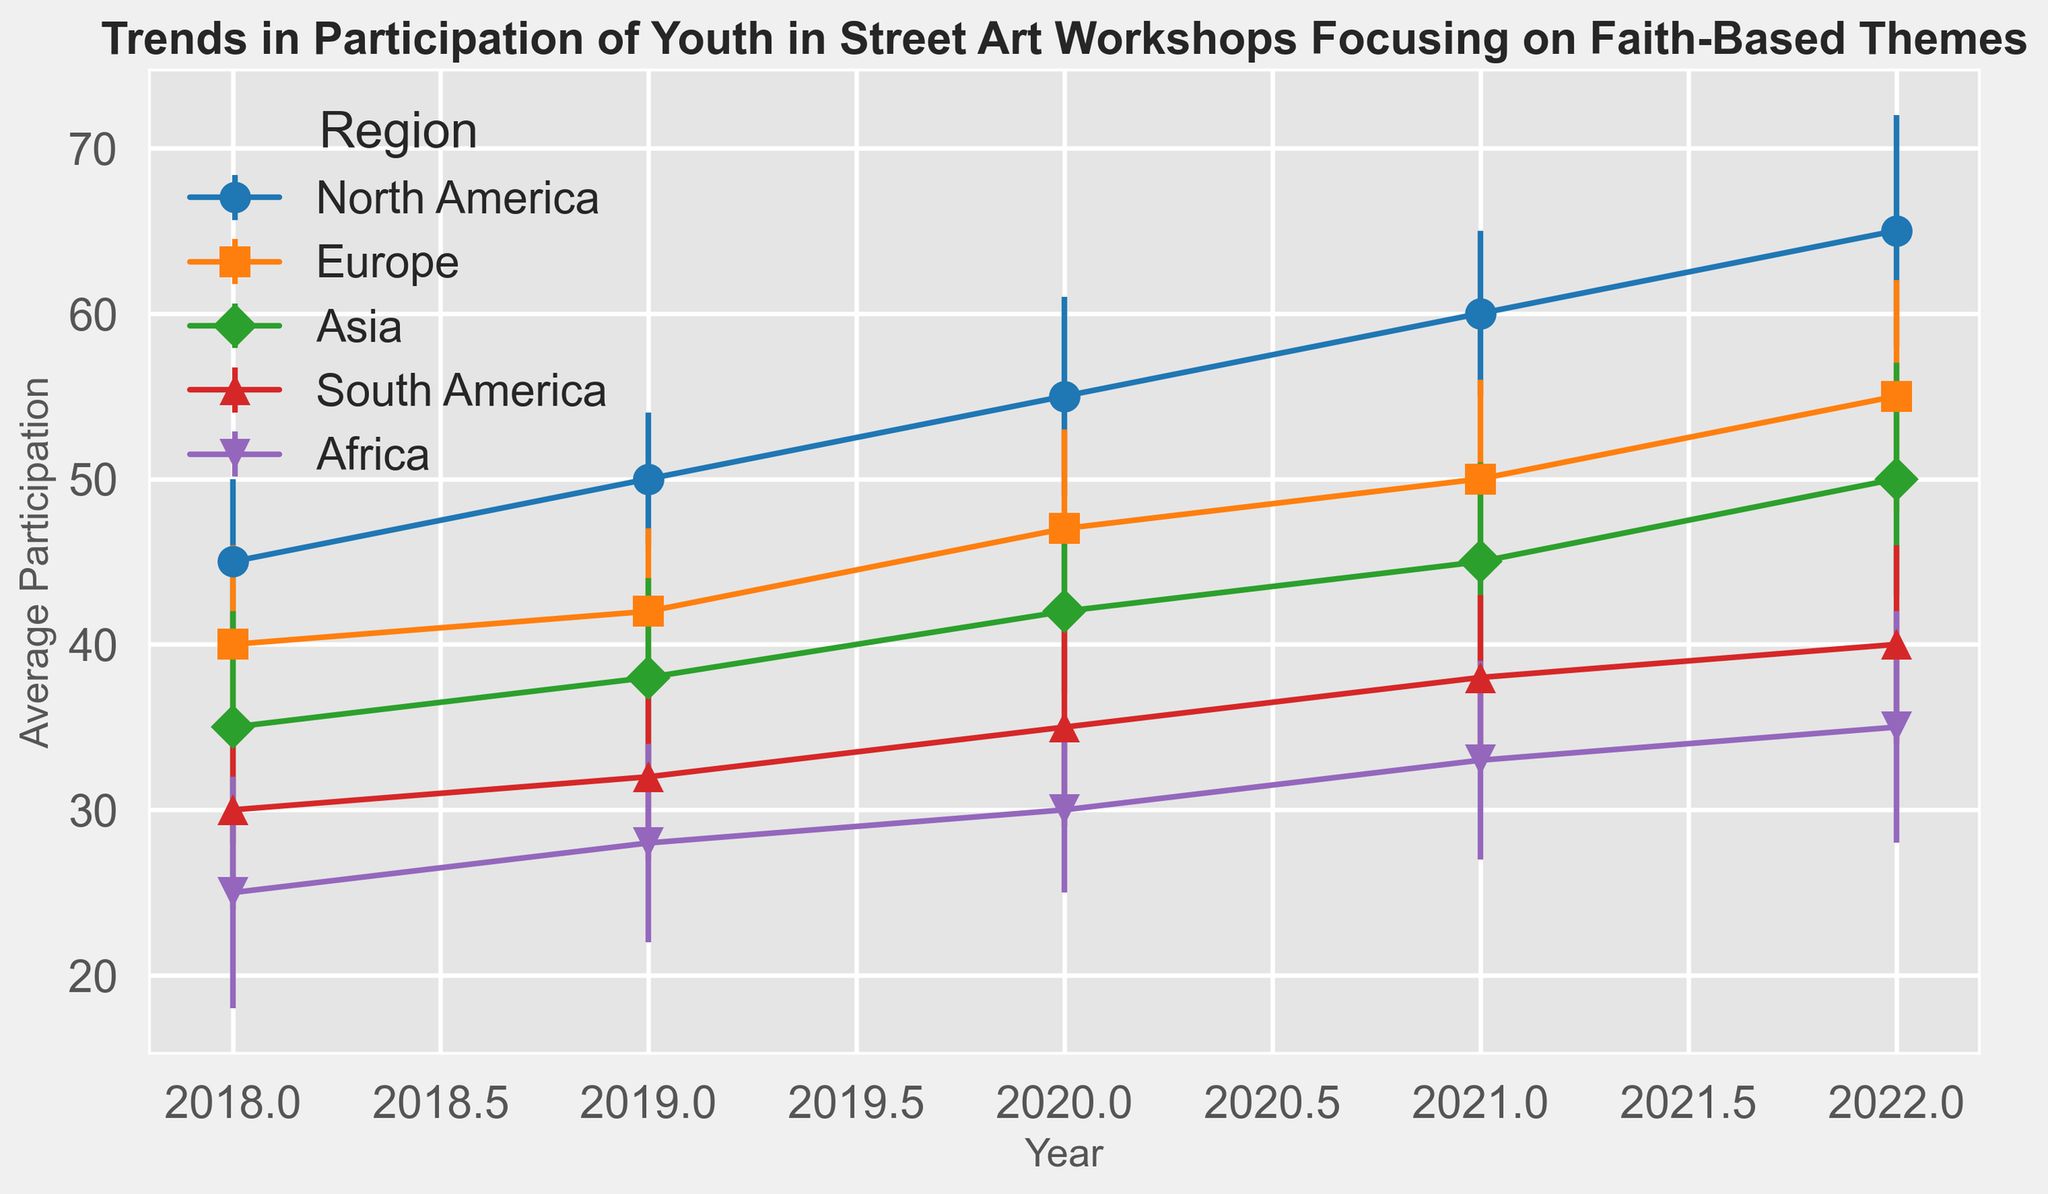Which region shows the highest average participation in 2022? To find out which region has the highest average participation in 2022, check the plot and look for the highest value on the vertical axis for the year 2022. North America has the highest average participation at that point.
Answer: North America What is the trend in average participation for Asia from 2018 to 2022? Observe the lines representing the average participation over the years for Asia. The trend shows a consistent increase in participation numbers from 35 in 2018 to 50 in 2022.
Answer: Increasing Which region had more workshops in 2020, Europe or North America? Although the chart primarily shows average participation, look for the relative number of data points for 2020 within each region. There are more data points (workshops) in North America for 2020 compared to Europe.
Answer: North America Compare the average participation in 2020 between Africa and South America. Which region had the higher average participation? Observe the lines for Africa and South America for the year 2020. Africa's average participation is 30, while South America's is 35. South America has the higher average participation.
Answer: South America How does the average participation in Europe in 2019 compare to that in North America in the same year? For comparison, locate the values for Europe and North America in 2019. Europe has an average participation of 42, whereas North America's average participation is 50.
Answer: North America By how much does the average participation in North America increase from 2018 to 2022? Calculate the difference between the average participation in North America in 2022 (65) and 2018 (45). The increase is 65 - 45 = 20.
Answer: 20 What is the range of standard deviations for average participation in South America from 2018 to 2022? The standard deviations for South America from 2018 to 2022 are 6, 5, 6, 5, and 6. The range is the difference between the highest (7) and the lowest (5), which is 7 - 5 = 2.
Answer: 2 Which year saw the highest average participation in Europe, and what was the average participation that year? To find the year with the highest average participation in Europe, look at the data points for Europe across all years. The year with the highest average participation is 2022, with an average value of 55.
Answer: 2022, 55 How does the trend of average participation in Africa compare with that of South America from 2018 to 2022? Observe the lines for Africa and South America. Both exhibit an increasing trend in average participation from 2018 to 2022, with Africa rising from 25 to 35 and South America from 30 to 40.
Answer: Both increasing What is the error range for the average participation in Asia in 2021? Identify the error bar for Asia in 2021. The average participation is 45 with a standard deviation of 6, so the range would be 45 ± 6, which gives a range of [39, 51].
Answer: [39, 51] 